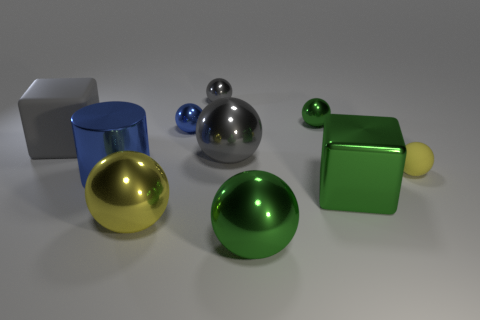Are there any tiny balls made of the same material as the large gray block?
Your response must be concise. Yes. There is a big block that is right of the green metallic sphere that is in front of the small blue metallic object on the right side of the big blue cylinder; what color is it?
Ensure brevity in your answer.  Green. There is a block in front of the large gray shiny thing; does it have the same color as the tiny thing that is to the left of the small gray thing?
Your answer should be compact. No. Is there anything else of the same color as the metal block?
Your response must be concise. Yes. Are there fewer gray spheres that are on the left side of the large gray metal ball than blue metal objects?
Keep it short and to the point. Yes. What number of balls are there?
Keep it short and to the point. 7. There is a small blue shiny thing; does it have the same shape as the green object that is behind the tiny yellow matte ball?
Your response must be concise. Yes. Are there fewer green objects behind the yellow metal thing than green metal cubes right of the large green cube?
Ensure brevity in your answer.  No. Is there anything else that is the same shape as the big yellow object?
Keep it short and to the point. Yes. Do the yellow matte thing and the tiny blue object have the same shape?
Keep it short and to the point. Yes. 